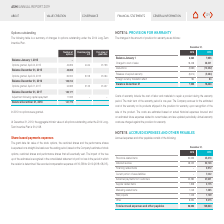According to Asm International Nv's financial document, What does cost of warranty include? the cost of labor and materials to repair a product during the warranty period. The document states: "Costs of warranty include the cost of labor and materials to repair a product during the warranty period. The main term of the warranty period is one ..." Also, How are warranty costs estimated? based on actual historical expenses incurred and on estimated future expenses related to current sales, and are updated periodically. The document states: "sale of the product. The costs are estimated based on actual historical expenses incurred and on estimated future expenses related to current sales, a..." Also, For what years are the costs of warranty information provided? The document shows two values: 2018 and 2019. From the document: "2018 2019 2018 2019..." Additionally, Which year had a larger difference in the balance between the start and the end of the year? According to the financial document, 2019. The relevant text states: "2018 2019..." Also, can you calculate: What is the percentage change in balance at end of year from 2018 to 2019? To answer this question, I need to perform calculations using the financial data. The calculation is: (16,424-7,955)/7,955, which equals 106.46 (percentage). This is based on the information: "Balance December 31 7,955 16,424 Balance December 31 7,955 16,424..." The key data points involved are: 16,424, 7,955. Also, can you calculate: What is the change in balance at start of year from 2018 to 2019? Based on the calculation:  7,955 - 6,562 , the result is 1393. This is based on the information: "Balance January 1 6,562 7,955 Balance January 1 6,562 7,955..." The key data points involved are: 6,562, 7,955. 